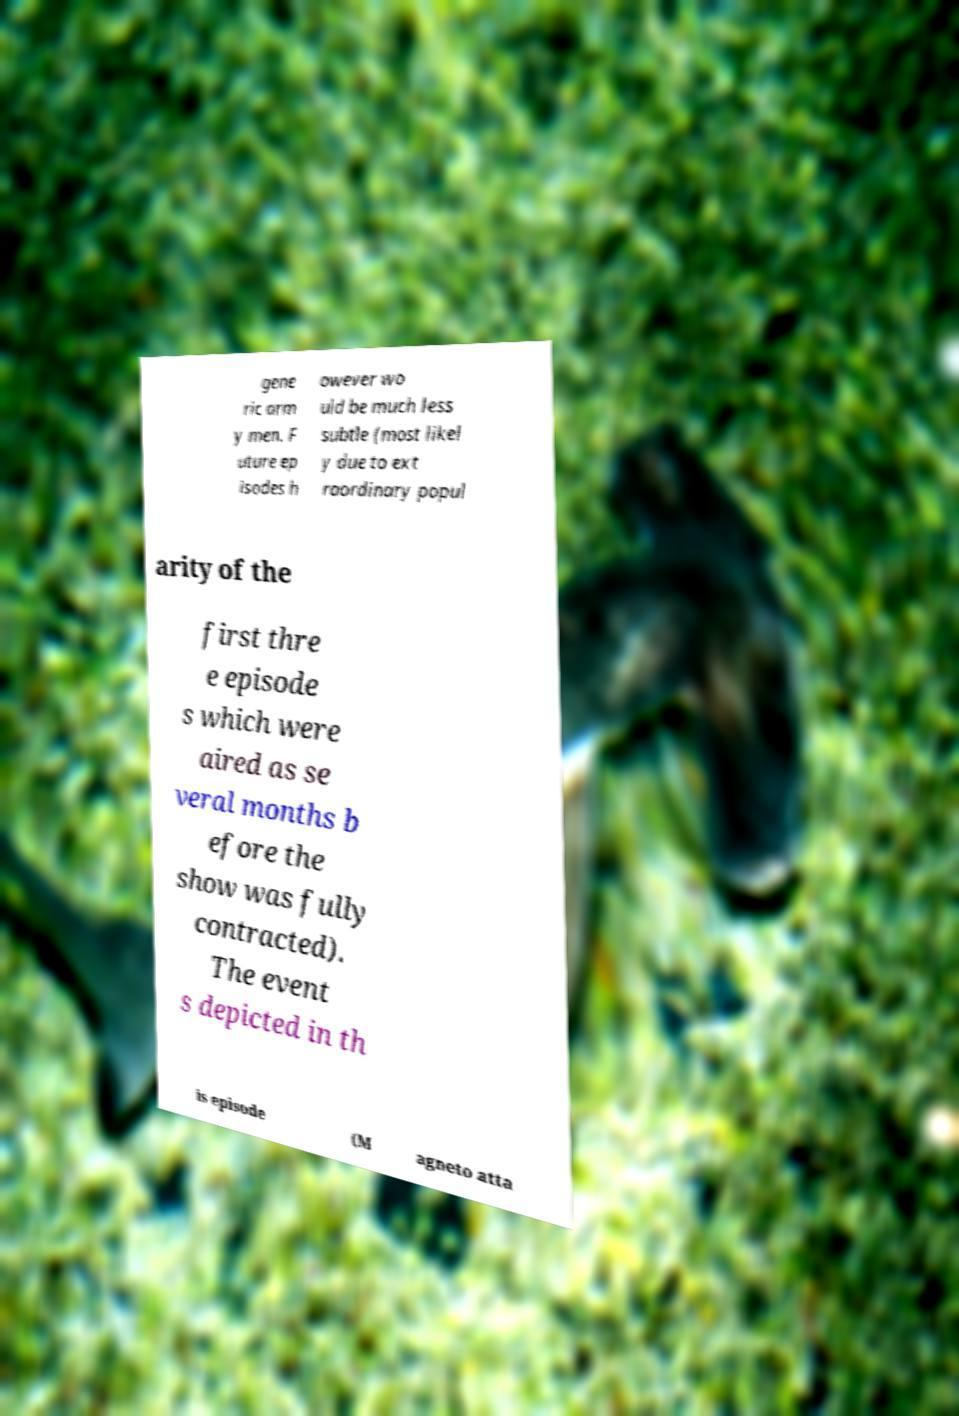Could you assist in decoding the text presented in this image and type it out clearly? gene ric arm y men. F uture ep isodes h owever wo uld be much less subtle (most likel y due to ext raordinary popul arity of the first thre e episode s which were aired as se veral months b efore the show was fully contracted). The event s depicted in th is episode (M agneto atta 